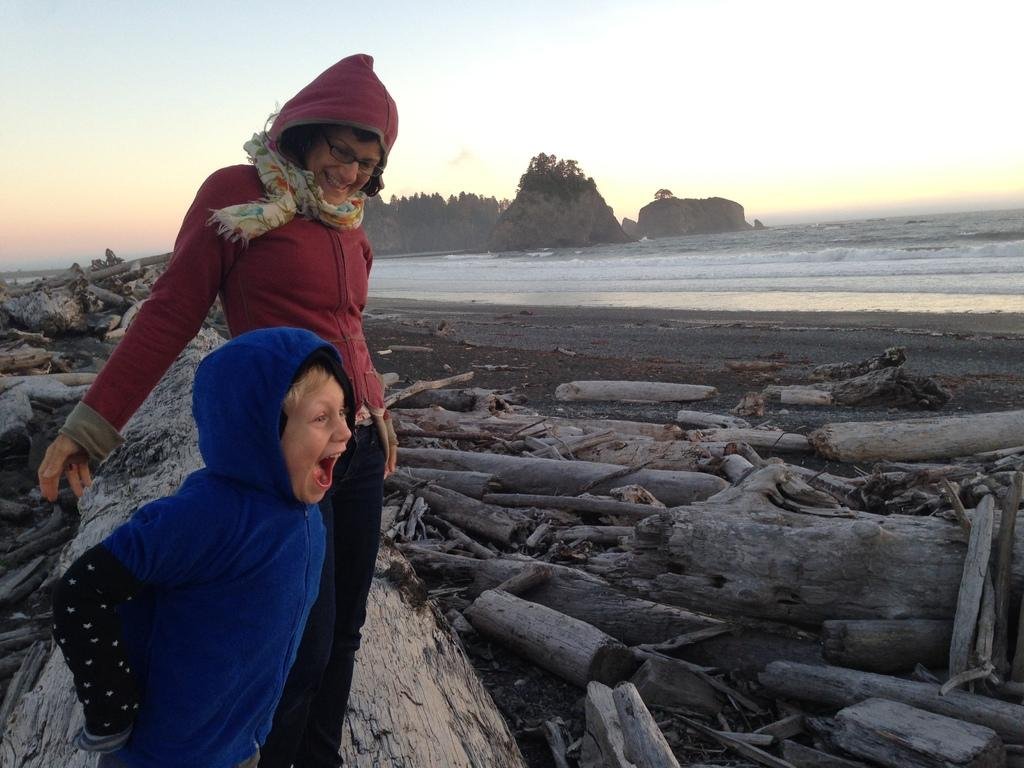Who are the people in the image? There is a woman and a boy in the image. What are the woman and the boy wearing? Both the woman and the boy are wearing caps and jackets. What can be seen on the ground in the image? There are tree barks and water visible in the image. What type of vegetation is present in the image? There are trees in the image. What is the condition of the sky in the image? The sky is cloudy in the image. What type of substance is the woman using to clean the boy's feet in the image? There is no indication in the image that the woman is cleaning the boy's feet or using any substance for that purpose. How many slaves are visible in the image? There are no slaves present in the image; it features a woman and a boy wearing caps and jackets. 